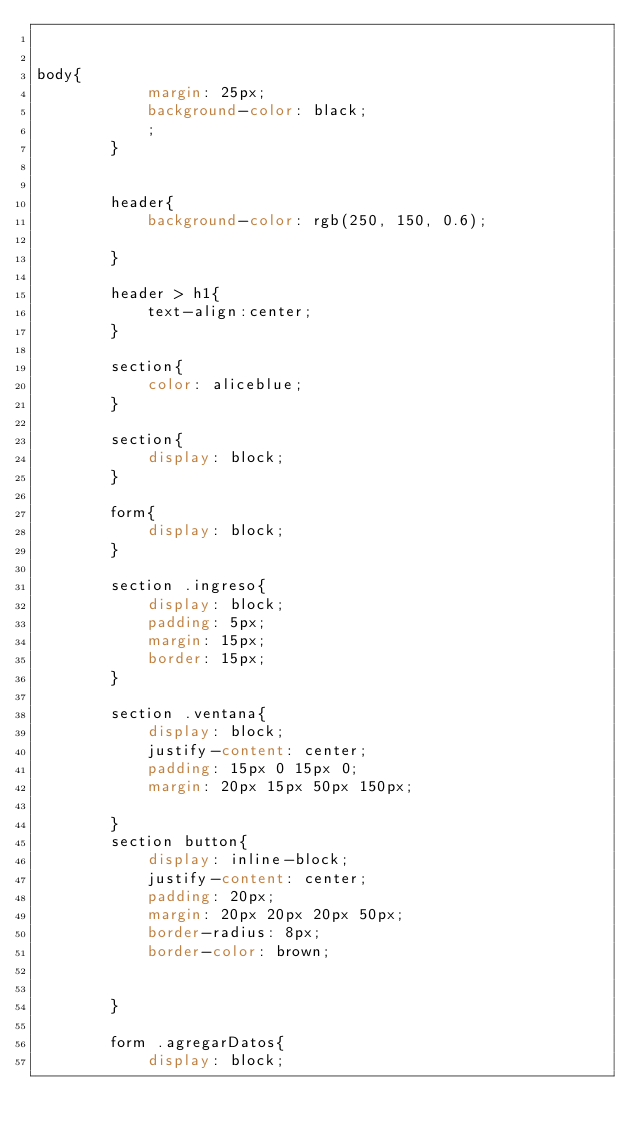Convert code to text. <code><loc_0><loc_0><loc_500><loc_500><_CSS_>

body{
            margin: 25px;
            background-color: black; 
            ;
        }
        
        
        header{
            background-color: rgb(250, 150, 0.6); 
         
        }

        header > h1{
            text-align:center;
        }

        section{
            color: aliceblue;
        }

        section{
            display: block;
        }

        form{
            display: block;
        }
        
        section .ingreso{
            display: block;
            padding: 5px;
            margin: 15px;
            border: 15px;
        }

        section .ventana{
            display: block;
            justify-content: center;
            padding: 15px 0 15px 0;
            margin: 20px 15px 50px 150px;
            
        }
        section button{
            display: inline-block;
            justify-content: center;
            padding: 20px;
            margin: 20px 20px 20px 50px;
            border-radius: 8px;
            border-color: brown;
            
            
        }

        form .agregarDatos{
            display: block;</code> 